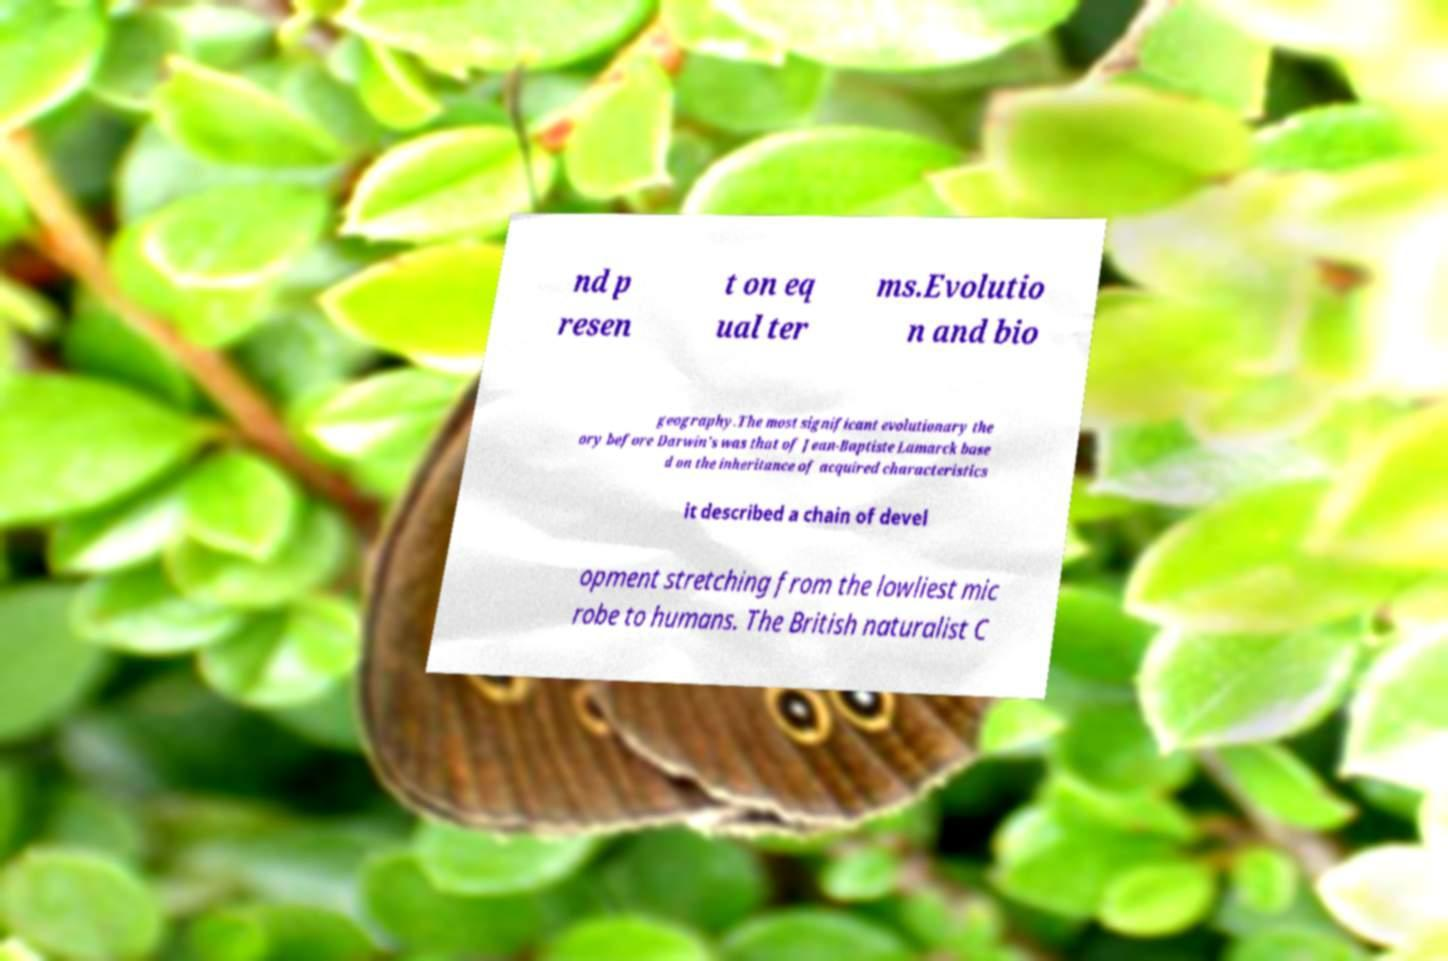What messages or text are displayed in this image? I need them in a readable, typed format. nd p resen t on eq ual ter ms.Evolutio n and bio geography.The most significant evolutionary the ory before Darwin's was that of Jean-Baptiste Lamarck base d on the inheritance of acquired characteristics it described a chain of devel opment stretching from the lowliest mic robe to humans. The British naturalist C 